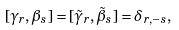Convert formula to latex. <formula><loc_0><loc_0><loc_500><loc_500>[ \gamma _ { r } , \beta _ { s } ] = [ { \tilde { \gamma } } _ { r } , { \tilde { \beta } } _ { s } ] = \delta _ { r , - s } ,</formula> 